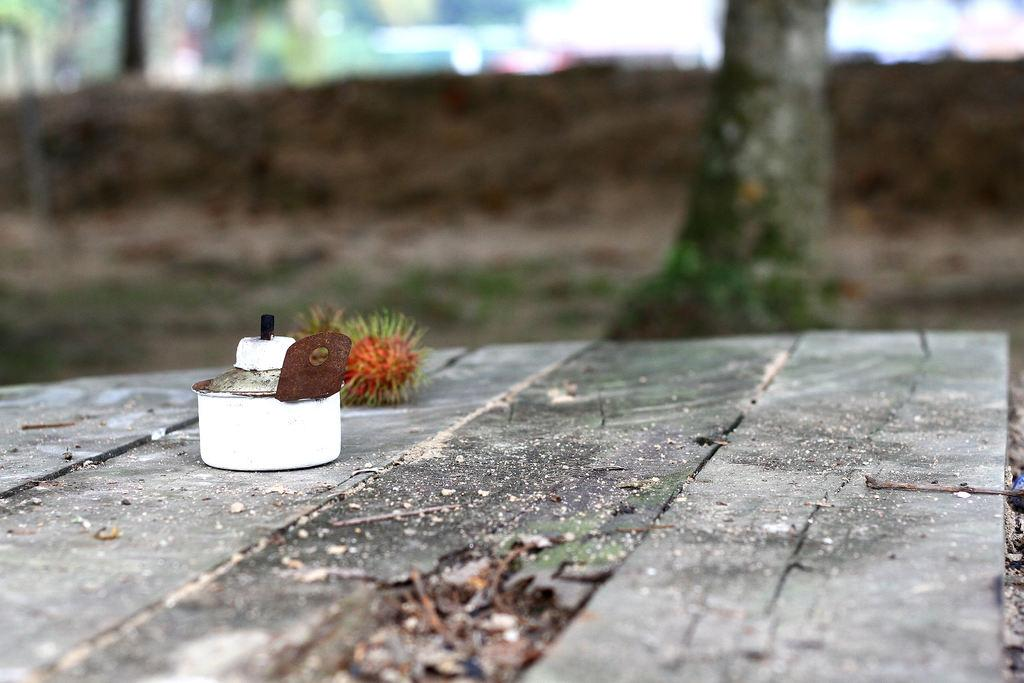What is the color of the main object in the image? The main object in the image is white. What type of surface is the object placed on? The object is on a wooden floor. What can be seen in the background of the image? There is a tree and other objects in the background of the image. What type of yam is being prepared by the brother in the image? There is no brother or yam present in the image. 